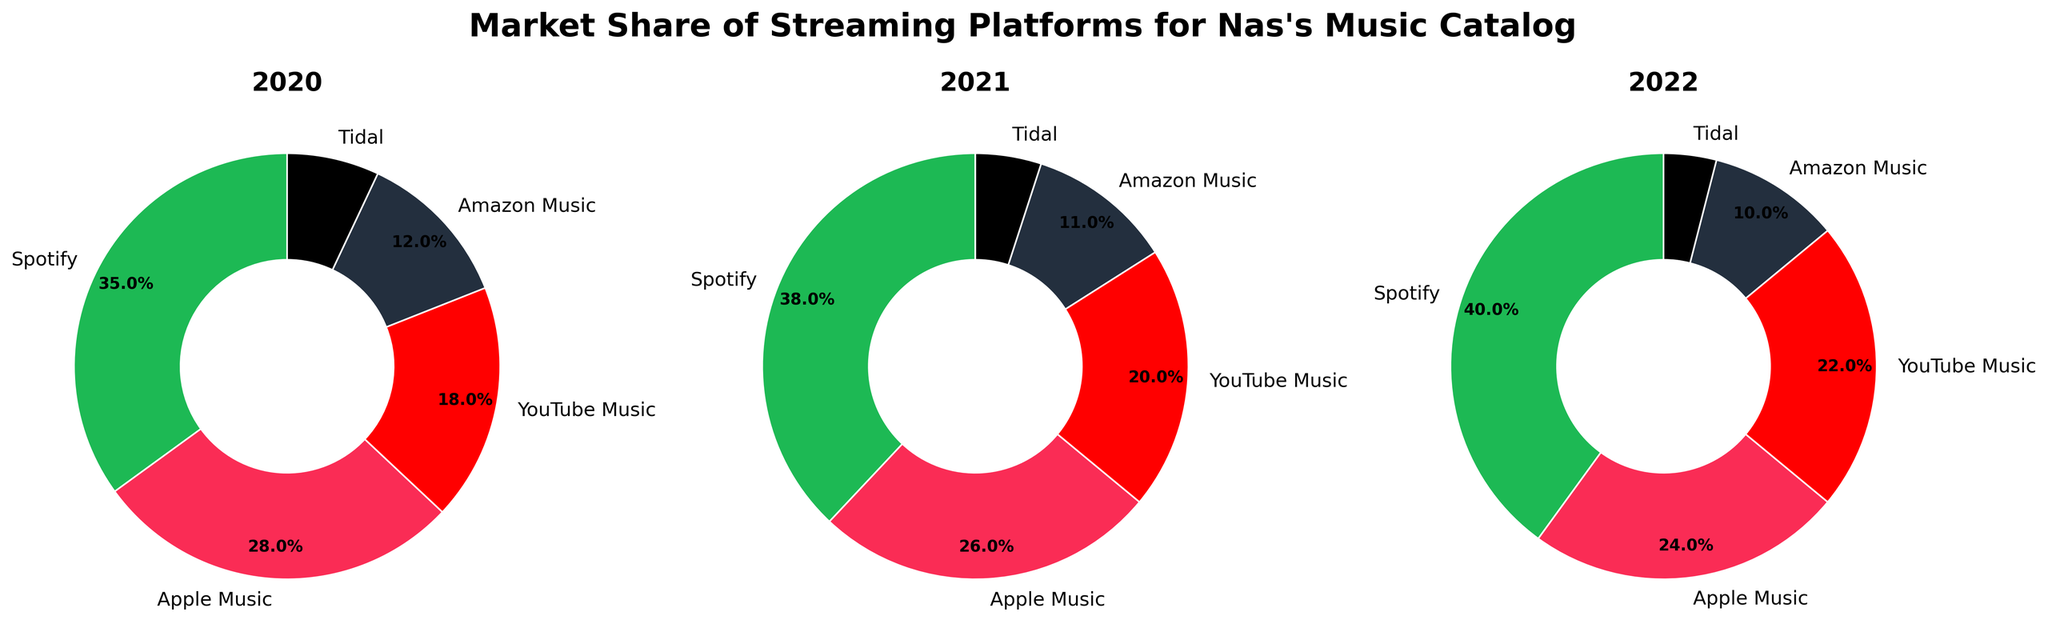What is the title of the figure? The title of the figure is always prominently displayed, usually at the top center of the plot. It can be read directly without any calculations.
Answer: Market Share of Streaming Platforms for Nas's Music Catalog How many pie charts are there in the figure? By visually counting the number of distinct circular plots (pie charts) displayed within the figure, the total number can be determined.
Answer: 3 What is the market share of Apple Music in 2020? Identify the pie chart labeled "2020" and look for the sector associated with Apple Music. The percentage shown within this sector indicates the market share.
Answer: 28% Which streaming platform had the highest market share in 2021? Refer to the pie chart labeled "2021". Identify the sector with the largest size (or highest percentage value). The label of this sector will be the platform with the highest market share.
Answer: Spotify By how much did YouTube Music's market share change from 2020 to 2022? Locate the sectors for YouTube Music in the 2020 and 2022 pie charts. Note their respective percentages and calculate the difference between the two values.
Answer: 22% - 18% = 4% increase Which year had the smallest market share for Tidal? Examine the Tidal sectors in each year's pie chart (2020, 2021, and 2022). Compare the percentages and identify the year with the lowest value.
Answer: 2022 What is the average market share of Amazon Music across all three years? Look for the market share values for Amazon Music in each pie chart (2020, 2021, 2022). Sum these values and divide by the number of years (3) to find the average.
Answer: (12% + 11% + 10%) / 3 = 11% Which platform consistently maintained or increased its market share from 2020 to 2022? Check each platform's sectors across each year's pie chart and compare their percentages. Identify the platforms where market share did not decrease in any year.
Answer: Spotify and YouTube Music In 2020, how much larger was Spotify's market share than Tidal's? Identify the market shares of Spotify and Tidal for the year 2020. Subtract Tidal's percentage from Spotify's to find the difference.
Answer: 35% - 7% = 28% Is the combined market share of Apple Music and YouTube Music in 2021 greater than that of Spotify alone in 2021? Add the market shares of Apple Music and YouTube Music for 2021. Compare the total with the market share of Spotify for the same year to determine which is greater.
Answer: 26% + 20% = 46%, which is greater than 38% 